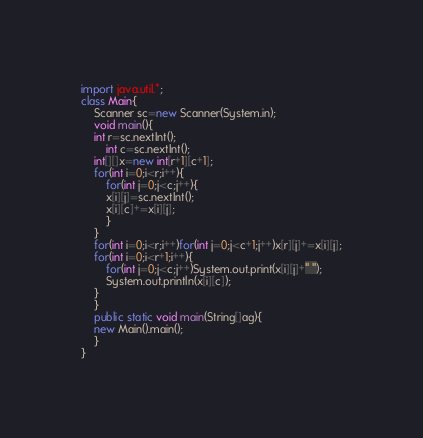Convert code to text. <code><loc_0><loc_0><loc_500><loc_500><_Java_>import java.util.*;
class Main{
    Scanner sc=new Scanner(System.in);
    void main(){
	int r=sc.nextInt();
        int c=sc.nextInt();
	int[][]x=new int[r+1][c+1];
	for(int i=0;i<r;i++){
	    for(int j=0;j<c;j++){
		x[i][j]=sc.nextInt();
		x[i][c]+=x[i][j];
	    }
	}
	for(int i=0;i<r;i++)for(int j=0;j<c+1;j++)x[r][j]+=x[i][j];
	for(int i=0;i<r+1;i++){
	    for(int j=0;j<c;j++)System.out.print(x[i][j]+" ");
	    System.out.println(x[i][c]);
	}
    }
    public static void main(String[]ag){
	new Main().main();
    }
}</code> 